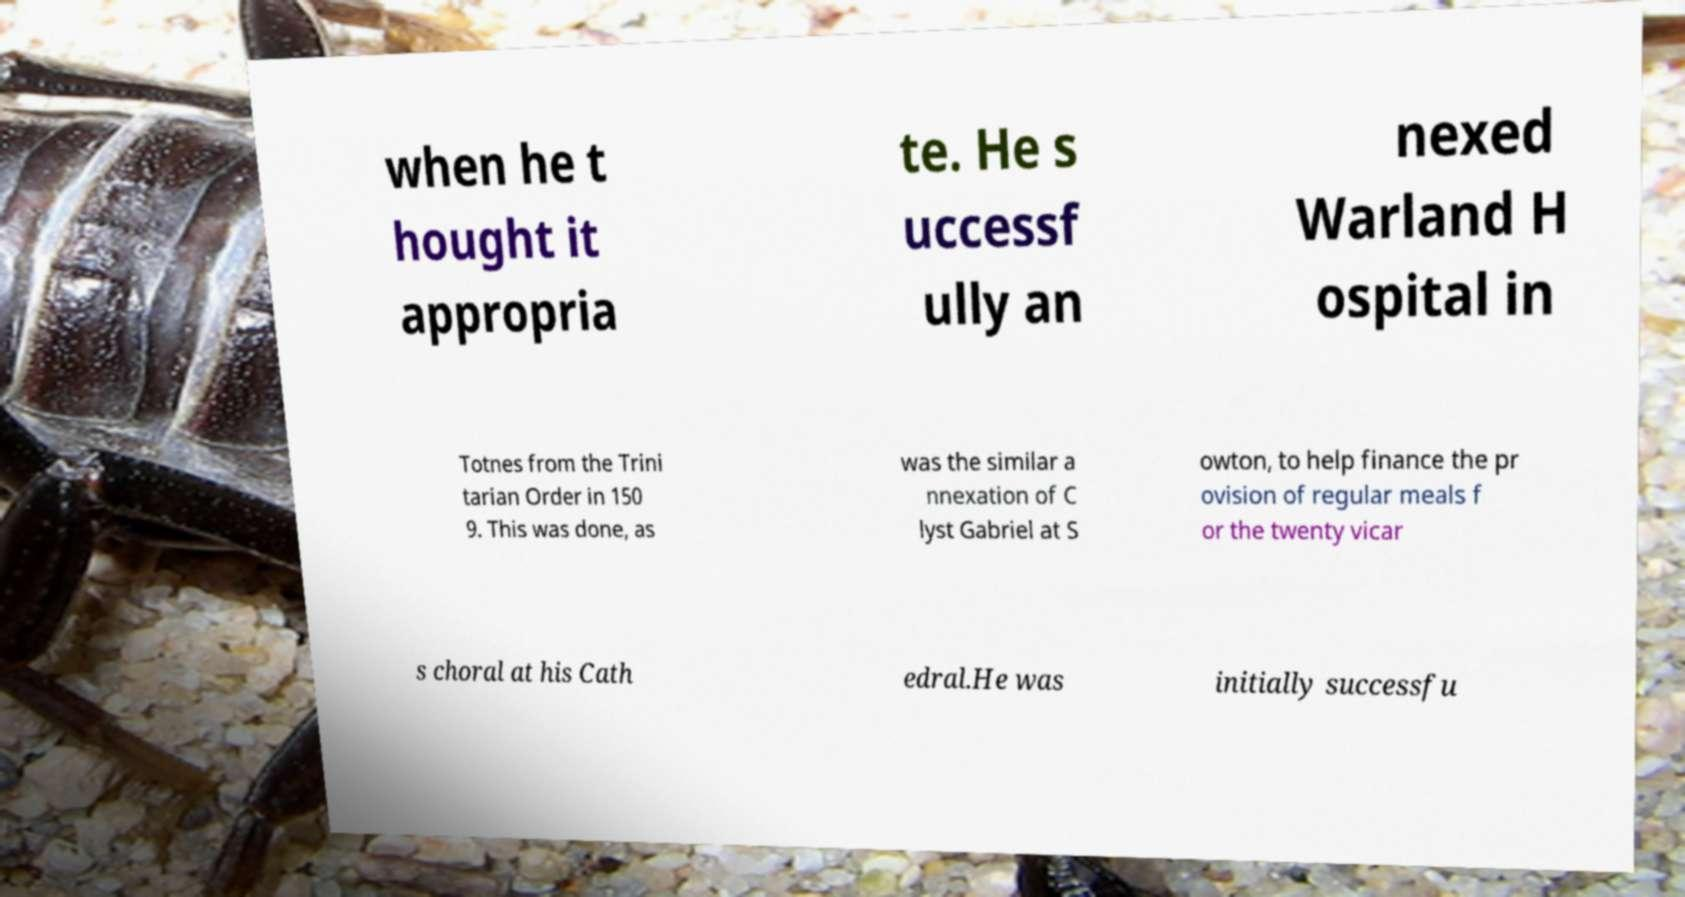I need the written content from this picture converted into text. Can you do that? when he t hought it appropria te. He s uccessf ully an nexed Warland H ospital in Totnes from the Trini tarian Order in 150 9. This was done, as was the similar a nnexation of C lyst Gabriel at S owton, to help finance the pr ovision of regular meals f or the twenty vicar s choral at his Cath edral.He was initially successfu 